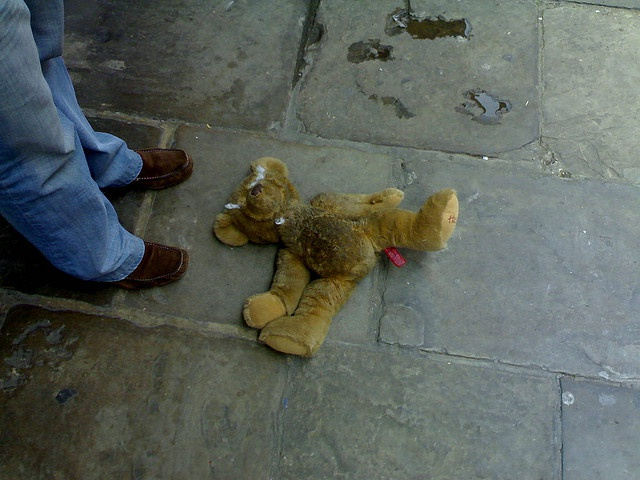Describe the objects in this image and their specific colors. I can see people in black, navy, blue, and gray tones and teddy bear in gray, olive, and black tones in this image. 